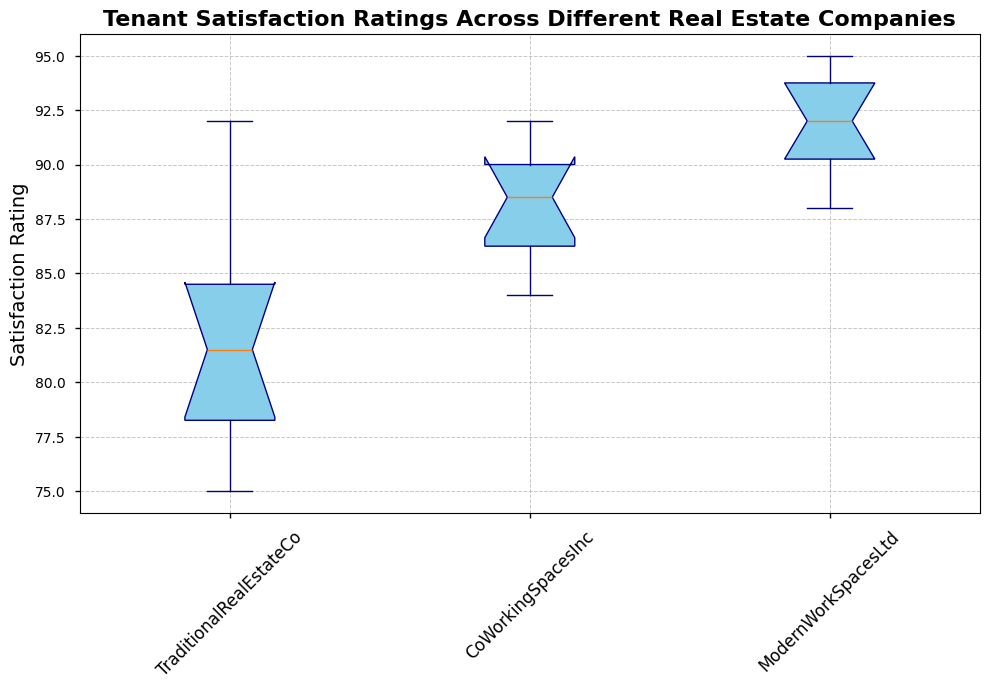What is the median Tenant Satisfaction Rating for TraditionalRealEstateCo? The median is found by ordering the ratings and identifying the middle value. Ordered ratings for TraditionalRealEstateCo: [75, 77, 78, 79, 81, 82, 83, 85, 88, 92]. The middle values are 81 and 82; the median is the average of these two: (81 + 82) / 2 = 81.5
Answer: 81.5 Which company has the highest median Tenant Satisfaction Rating? To determine this, compare the median values of all companies. Based on the box plot, the medians are: TraditionalRealEstateCo (approx. 81.5), CoWorkingSpacesInc (approx. 89), and ModernWorkSpacesLtd (approx. 92). The highest median is for ModernWorkSpacesLtd.
Answer: ModernWorkSpacesLtd What is the range of Tenant Satisfaction Ratings for CoWorkingSpacesInc? The range is the difference between the maximum and minimum values in the dataset for CoWorkingSpacesInc. The minimum is 84 and the maximum is 92: 92 - 84 = 8
Answer: 8 Which company's box has the smallest interquartile range (IQR)? IQR is the difference between the third quartile (75th percentile) and the first quartile (25th percentile). Based on the box plot visuals, TraditionalRealEstateCo has the widest box, CoWorkingSpacesInc and ModernWorkSpacesLtd have similar IQRs, but ModernWorkSpacesLtd's box appears slightly narrower.
Answer: ModernWorkSpacesLtd Between CoWorkingSpacesInc and ModernWorkSpacesLtd, which company shows a greater overall spread in Tenant Satisfaction Ratings? Overall spread is determined by the range. CoWorkingSpacesInc ranges from 84 to 92, giving an 8-point spread. ModernWorkSpacesLtd ranges from 88 to 95, giving a 7-point spread. Therefore, CoWorkingSpacesInc has the greater spread.
Answer: CoWorkingSpacesInc Looking at the whiskers, which company's ratings show the least variability? The variability is reflected in the length of the whiskers. Shorter whiskers indicate less variability. ModernWorkSpacesLtd has the shortest whiskers, indicating the least variability.
Answer: ModernWorkSpacesLtd What is the highest Tenant Satisfaction Rating recorded for ModernWorkSpacesLtd? The highest rating is represented by the upper whisker of the box plot for ModernWorkSpacesLtd, which visually aligns with 95.
Answer: 95 How does the lower quartile for TraditionalRealEstateCo compare to the lower quartile for CoWorkingSpacesInc? The lower quartile is the 25th percentile. In the box plot, TraditionalRealEstateCo's lower quartile is around 78, and CoWorkingSpacesInc's lower quartile is around 85. Thus, CoWorkingSpacesInc's lower quartile is higher.
Answer: CoWorkingSpacesInc Which company’s box plot suggests a better consistency in Tenant Satisfaction Ratings? Consistency can be inferred from a smaller interquartile range (IQR) and shorter whiskers. ModernWorkSpacesLtd’s box plot shows a smaller IQR and shorter whiskers, indicating better consistency.
Answer: ModernWorkSpacesLtd 